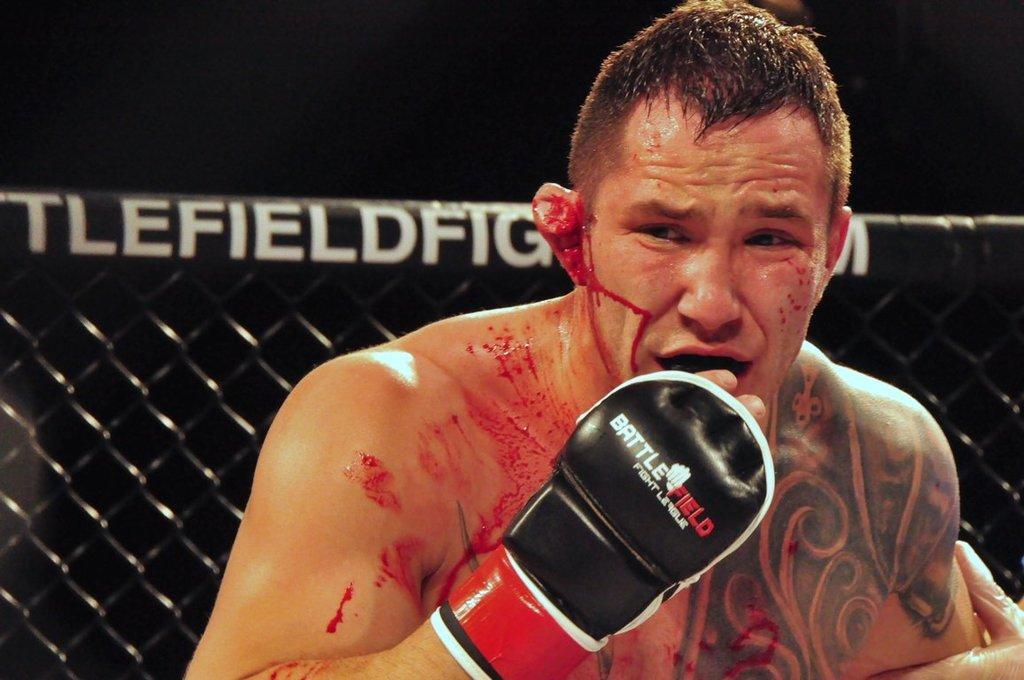In one or two sentences, can you explain what this image depicts? In this image I can see a person bleeding and wearing black, red and white colored glove. I can see the black colored metal fence and the dark background. 